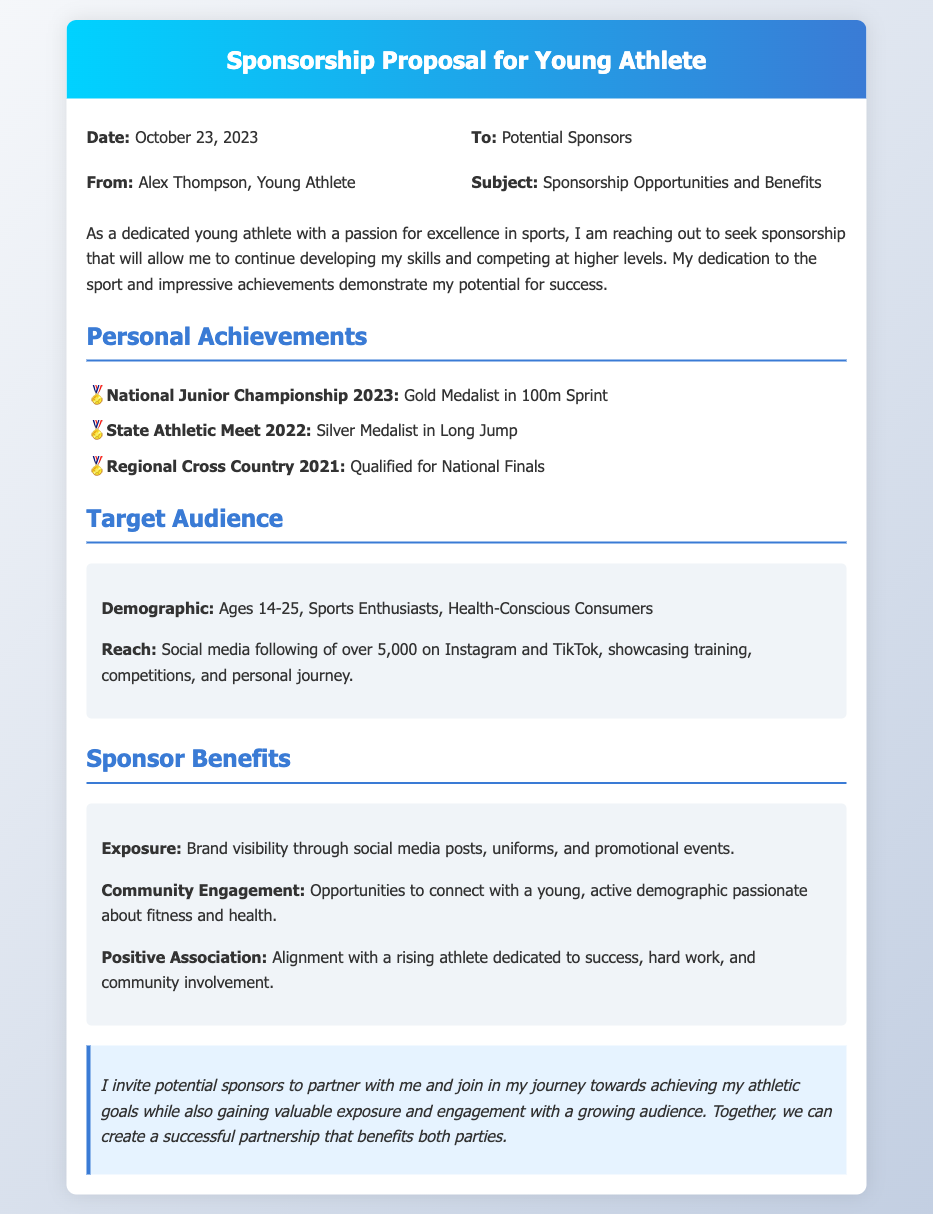What is the date of the memo? The date is clearly stated at the top of the memo in the meta section, which is October 23, 2023.
Answer: October 23, 2023 Who is the sender of the memo? The sender's name is mentioned just below the "To:" line in the meta section, identifying the individual reaching out.
Answer: Alex Thompson What achievement is highlighted under the National Junior Championship? The achievement listed under National Junior Championship shows the specific accolade earned by the athlete in this event, which is a gold medal.
Answer: Gold Medalist in 100m Sprint What is the demographic of the target audience? The demographic is listed in the target audience section, specifying the age range and interests.
Answer: Ages 14-25, Sports Enthusiasts, Health-Conscious Consumers How many social media followers does the athlete have? The number of social media followers is indicated in the target audience section, quantifying the athlete's reach online.
Answer: Over 5,000 What type of benefits do sponsors receive according to the memo? The benefits for sponsors are outlined, including exposure and community engagement among other factors, answering what sponsors gain.
Answer: Brand visibility through social media posts What type of document is this? The structure and purpose of the memo indicate its intent to communicate sponsorship opportunities and benefits, categorizing it accordingly.
Answer: Sponsorship Proposal Why is the athlete seeking sponsorship? The athlete expresses a clear motive for seeking sponsorship in the opening paragraph, summarizing the purpose of the memo.
Answer: To continue developing skills and competing at higher levels 